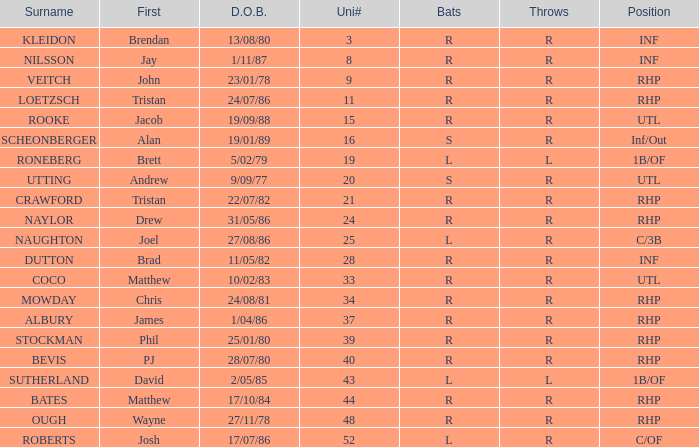How many uni numbers possess s bats and utl position? 1.0. 